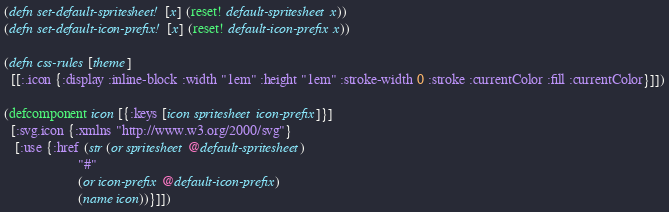Convert code to text. <code><loc_0><loc_0><loc_500><loc_500><_Clojure_>(defn set-default-spritesheet! [x] (reset! default-spritesheet x))
(defn set-default-icon-prefix! [x] (reset! default-icon-prefix x))

(defn css-rules [theme]
  [[:.icon {:display :inline-block :width "1em" :height "1em" :stroke-width 0 :stroke :currentColor :fill :currentColor}]])

(defcomponent icon [{:keys [icon spritesheet icon-prefix]}]
  [:svg.icon {:xmlns "http://www.w3.org/2000/svg"}
   [:use {:href (str (or spritesheet @default-spritesheet)
                     "#"
                     (or icon-prefix @default-icon-prefix)
                     (name icon))}]])

</code> 